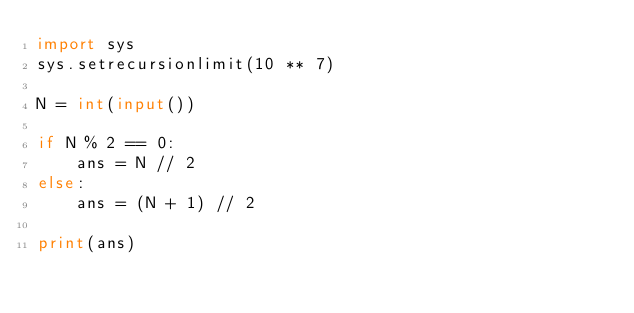<code> <loc_0><loc_0><loc_500><loc_500><_Python_>import sys
sys.setrecursionlimit(10 ** 7)

N = int(input())

if N % 2 == 0:
    ans = N // 2
else:
    ans = (N + 1) // 2

print(ans)
</code> 